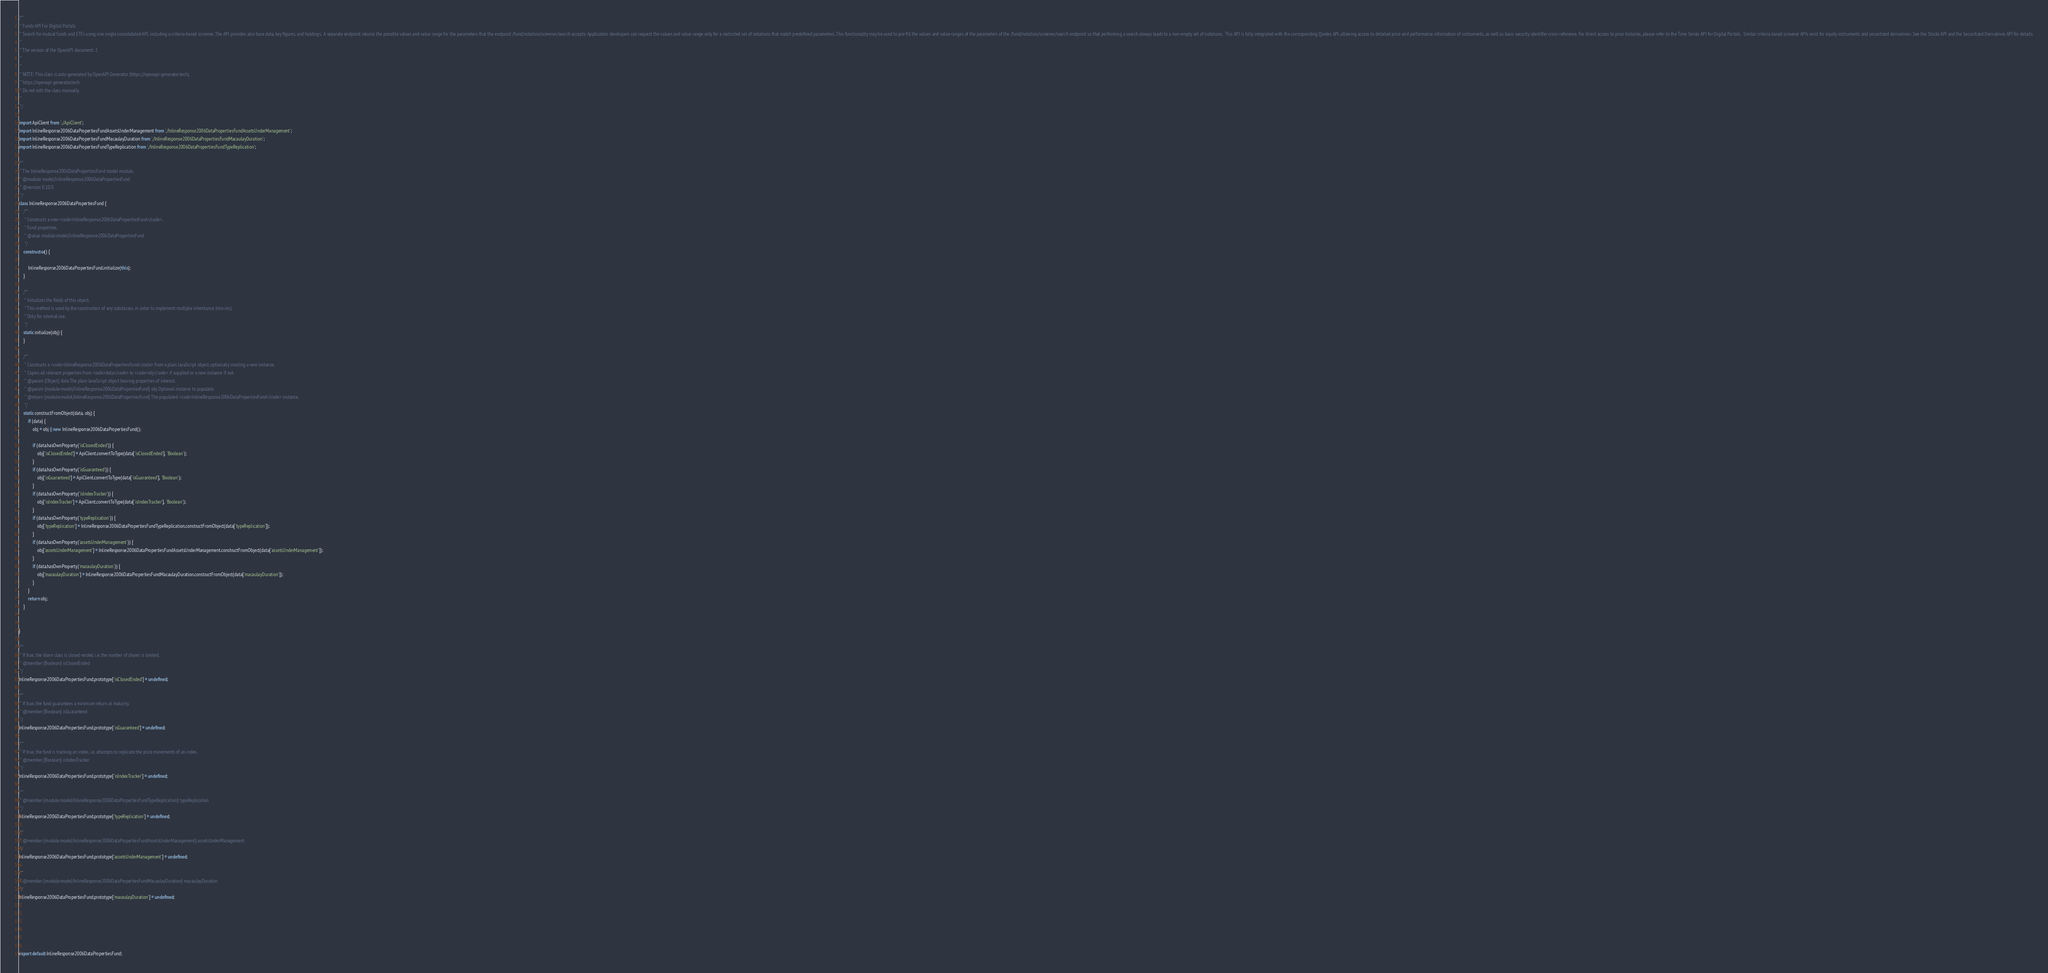<code> <loc_0><loc_0><loc_500><loc_500><_JavaScript_>/**
 * Funds API For Digital Portals
 * Search for mutual funds and ETFs using one single consolidated API, including a criteria-based screener. The API provides also base data, key figures, and holdings.  A separate endpoint returns the possible values and value range for the parameters that the endpoint /fund/notation/screener/search accepts: Application developers can request the values and value range only for a restricted set of notations that match predefined parameters. This functionality may be used to pre-fill the values and value ranges of the parameters of the /fund/notation/screener/search endpoint so that performing a search always leads to a non-empty set of notations.  This API is fully integrated with the corresponding Quotes API, allowing access to detailed price and performance information of instruments, as well as basic security identifier cross-reference. For direct access to price histories, please refer to the Time Series API for Digital Portals.  Similar criteria based screener APIs exist for equity instruments and securitized derivatives: See the Stocks API and the Securitized Derivatives API for details.
 *
 * The version of the OpenAPI document: 2
 * 
 *
 * NOTE: This class is auto generated by OpenAPI Generator (https://openapi-generator.tech).
 * https://openapi-generator.tech
 * Do not edit the class manually.
 *
 */

import ApiClient from '../ApiClient';
import InlineResponse2006DataPropertiesFundAssetsUnderManagement from './InlineResponse2006DataPropertiesFundAssetsUnderManagement';
import InlineResponse2006DataPropertiesFundMacaulayDuration from './InlineResponse2006DataPropertiesFundMacaulayDuration';
import InlineResponse2006DataPropertiesFundTypeReplication from './InlineResponse2006DataPropertiesFundTypeReplication';

/**
 * The InlineResponse2006DataPropertiesFund model module.
 * @module model/InlineResponse2006DataPropertiesFund
 * @version 0.10.0
 */
class InlineResponse2006DataPropertiesFund {
    /**
     * Constructs a new <code>InlineResponse2006DataPropertiesFund</code>.
     * Fund properties.
     * @alias module:model/InlineResponse2006DataPropertiesFund
     */
    constructor() { 
        
        InlineResponse2006DataPropertiesFund.initialize(this);
    }

    /**
     * Initializes the fields of this object.
     * This method is used by the constructors of any subclasses, in order to implement multiple inheritance (mix-ins).
     * Only for internal use.
     */
    static initialize(obj) { 
    }

    /**
     * Constructs a <code>InlineResponse2006DataPropertiesFund</code> from a plain JavaScript object, optionally creating a new instance.
     * Copies all relevant properties from <code>data</code> to <code>obj</code> if supplied or a new instance if not.
     * @param {Object} data The plain JavaScript object bearing properties of interest.
     * @param {module:model/InlineResponse2006DataPropertiesFund} obj Optional instance to populate.
     * @return {module:model/InlineResponse2006DataPropertiesFund} The populated <code>InlineResponse2006DataPropertiesFund</code> instance.
     */
    static constructFromObject(data, obj) {
        if (data) {
            obj = obj || new InlineResponse2006DataPropertiesFund();

            if (data.hasOwnProperty('isClosedEnded')) {
                obj['isClosedEnded'] = ApiClient.convertToType(data['isClosedEnded'], 'Boolean');
            }
            if (data.hasOwnProperty('isGuaranteed')) {
                obj['isGuaranteed'] = ApiClient.convertToType(data['isGuaranteed'], 'Boolean');
            }
            if (data.hasOwnProperty('isIndexTracker')) {
                obj['isIndexTracker'] = ApiClient.convertToType(data['isIndexTracker'], 'Boolean');
            }
            if (data.hasOwnProperty('typeReplication')) {
                obj['typeReplication'] = InlineResponse2006DataPropertiesFundTypeReplication.constructFromObject(data['typeReplication']);
            }
            if (data.hasOwnProperty('assetsUnderManagement')) {
                obj['assetsUnderManagement'] = InlineResponse2006DataPropertiesFundAssetsUnderManagement.constructFromObject(data['assetsUnderManagement']);
            }
            if (data.hasOwnProperty('macaulayDuration')) {
                obj['macaulayDuration'] = InlineResponse2006DataPropertiesFundMacaulayDuration.constructFromObject(data['macaulayDuration']);
            }
        }
        return obj;
    }


}

/**
 * If true, the share class is closed-ended, i.e. the number of shares is limited.
 * @member {Boolean} isClosedEnded
 */
InlineResponse2006DataPropertiesFund.prototype['isClosedEnded'] = undefined;

/**
 * If true, the fund guarantees a minimum return at maturity.
 * @member {Boolean} isGuaranteed
 */
InlineResponse2006DataPropertiesFund.prototype['isGuaranteed'] = undefined;

/**
 * If true, the fund is tracking an index, i.e. attempts to replicate the price movements of an index.
 * @member {Boolean} isIndexTracker
 */
InlineResponse2006DataPropertiesFund.prototype['isIndexTracker'] = undefined;

/**
 * @member {module:model/InlineResponse2006DataPropertiesFundTypeReplication} typeReplication
 */
InlineResponse2006DataPropertiesFund.prototype['typeReplication'] = undefined;

/**
 * @member {module:model/InlineResponse2006DataPropertiesFundAssetsUnderManagement} assetsUnderManagement
 */
InlineResponse2006DataPropertiesFund.prototype['assetsUnderManagement'] = undefined;

/**
 * @member {module:model/InlineResponse2006DataPropertiesFundMacaulayDuration} macaulayDuration
 */
InlineResponse2006DataPropertiesFund.prototype['macaulayDuration'] = undefined;






export default InlineResponse2006DataPropertiesFund;

</code> 